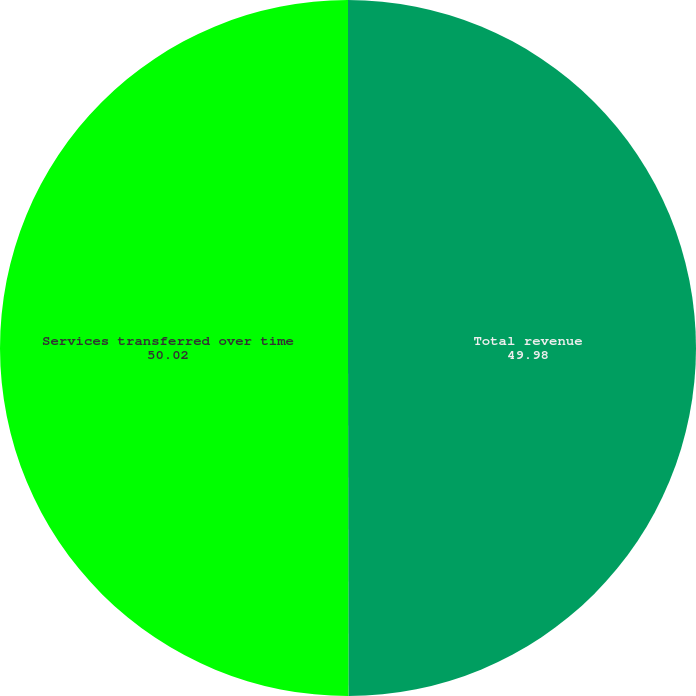Convert chart to OTSL. <chart><loc_0><loc_0><loc_500><loc_500><pie_chart><fcel>Total revenue<fcel>Services transferred over time<nl><fcel>49.98%<fcel>50.02%<nl></chart> 